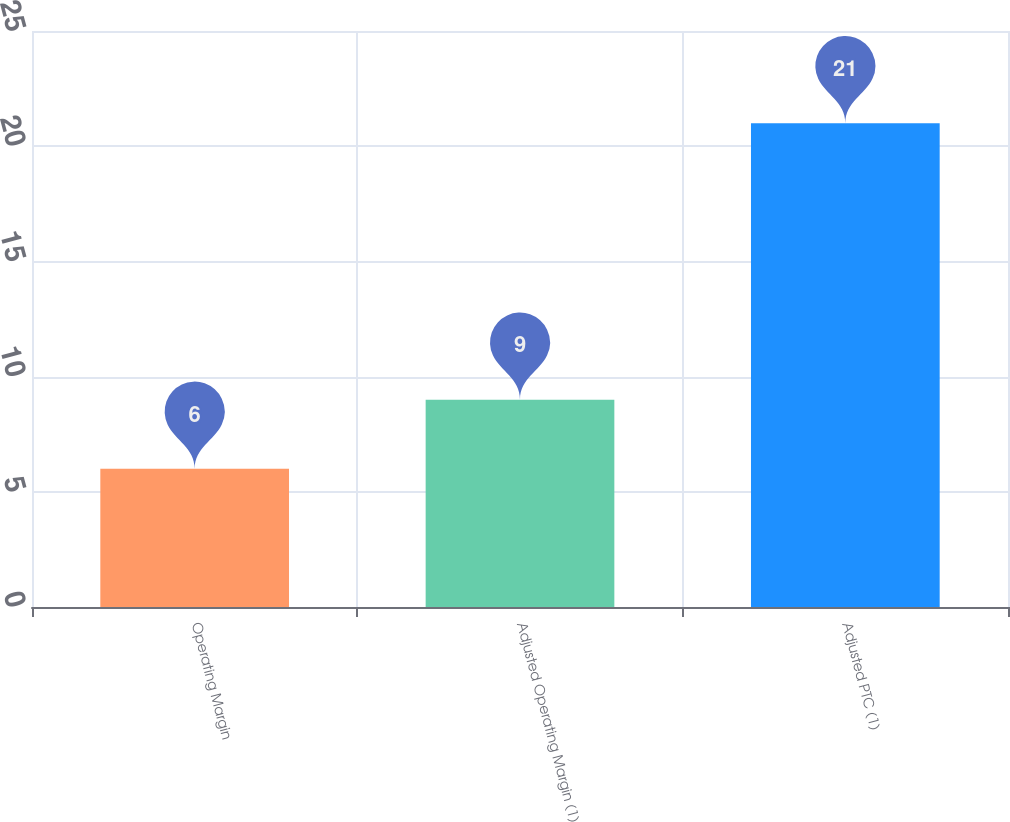Convert chart. <chart><loc_0><loc_0><loc_500><loc_500><bar_chart><fcel>Operating Margin<fcel>Adjusted Operating Margin (1)<fcel>Adjusted PTC (1)<nl><fcel>6<fcel>9<fcel>21<nl></chart> 